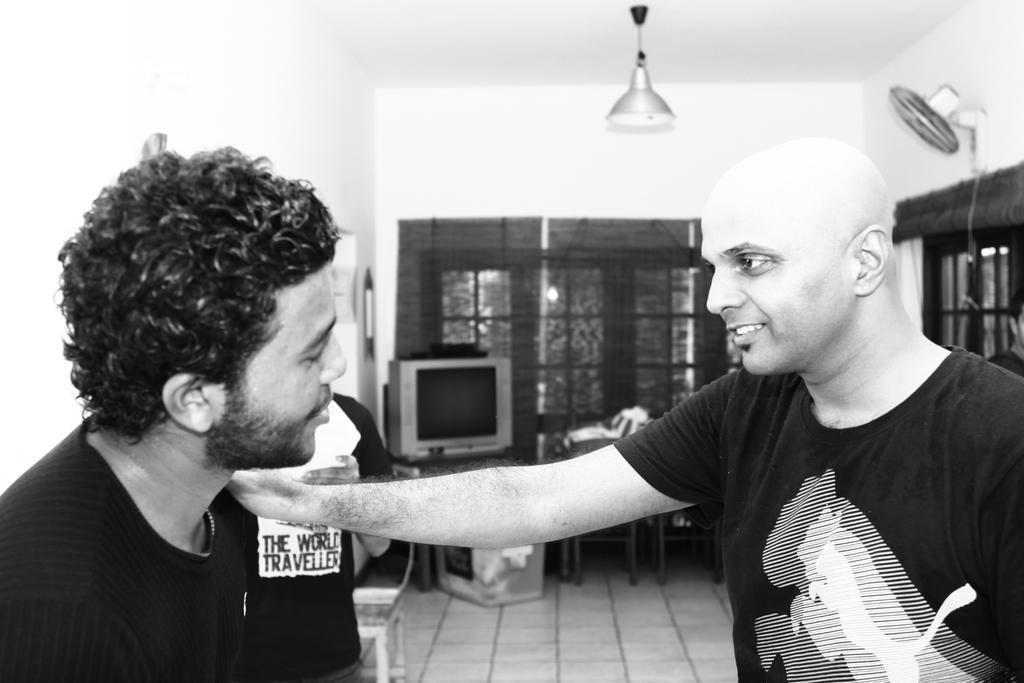What can be seen in the image involving people? There are people standing in the image. What electronic device is present in the image? There is a television in the image. What architectural feature is visible in the image? There are windows in the image. What appliance can be seen in the image? There is a fan in the image. What type of lighting is present in the image? There is a light hanging in the image. What part of the room's structure is visible in the image? The walls are visible in the image. What type of secretary is sitting next to the fan in the image? There is no secretary present in the image; it only shows people standing, a television, windows, a fan, a light, and walls. What type of sister is visible through the windows in the image? There is no sister visible through the windows in the image; only the people, television, windows, fan, light, and walls are present. 